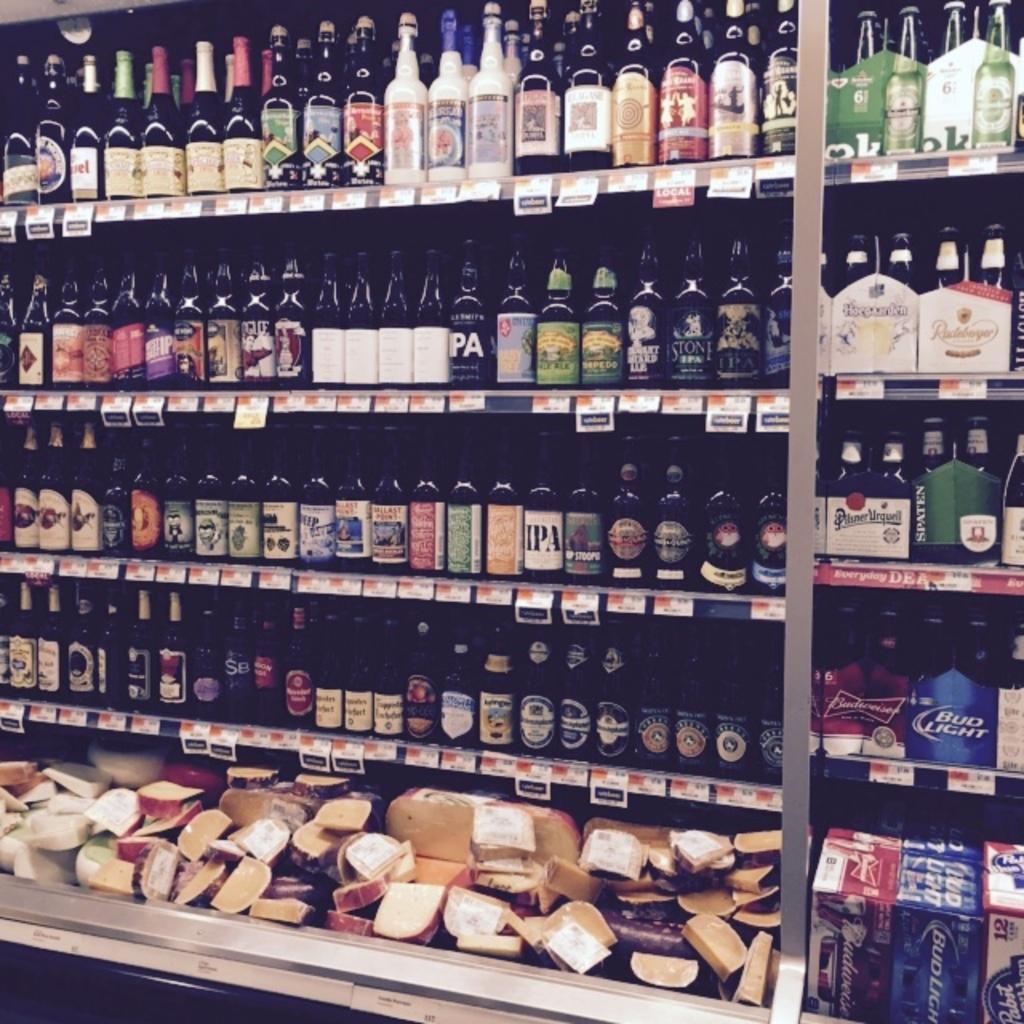Provide a one-sentence caption for the provided image. The extensive spirits and cheese selection includes Budweiser and Heineken. 